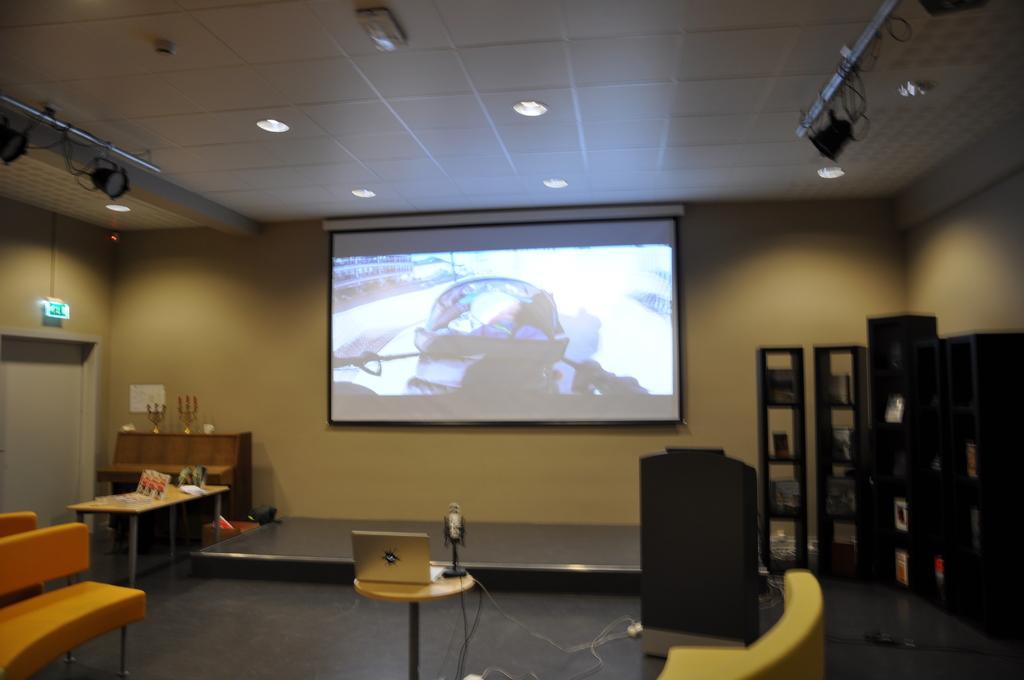Please provide a concise description of this image. This image is taken indoors. At the bottom of the image there is a floor. On the right side of the image there are a few cupboards. On the left side of the image there is an empty bench and a table with a few things on it. In the middle of the image there is a table with a laptop on it and there is a couch. In the background there is a wall with a projector screen on it. At the top of the image there is a ceiling with lights. 